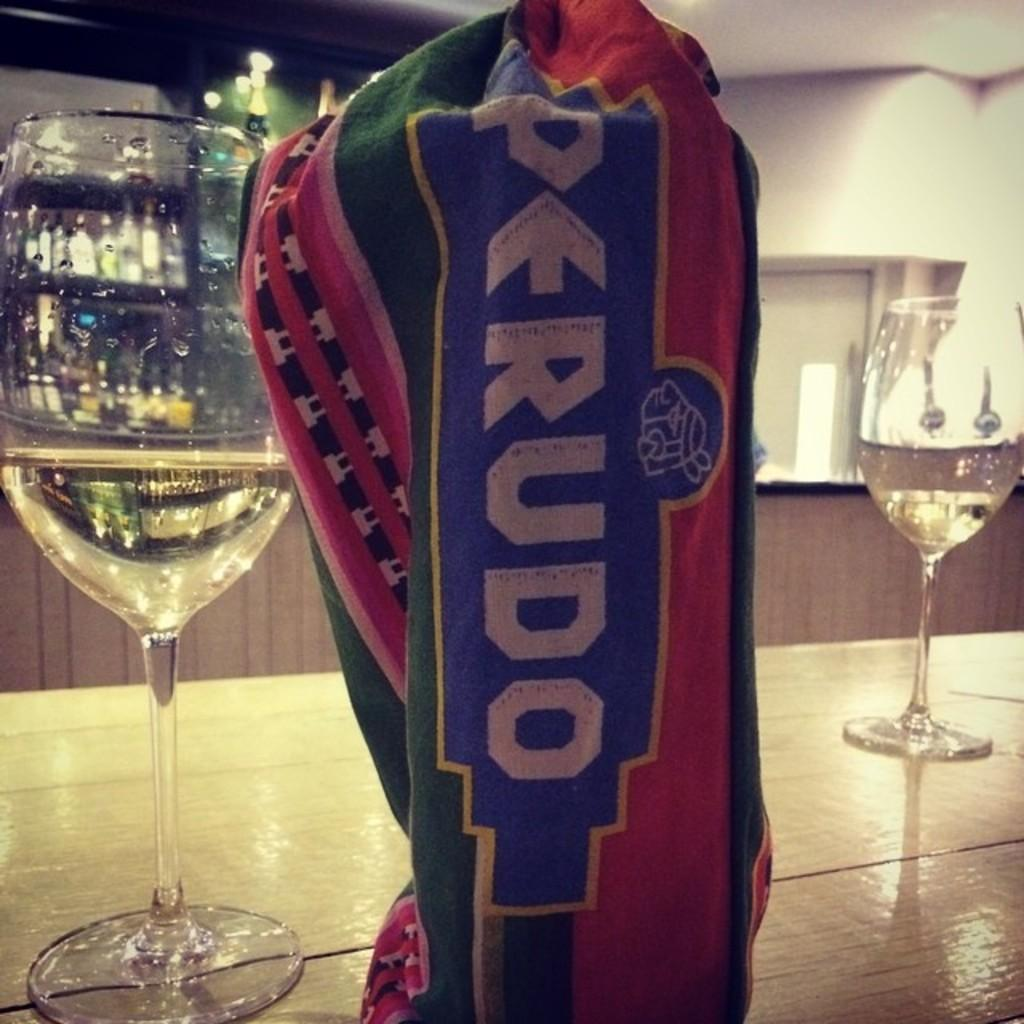<image>
Present a compact description of the photo's key features. multicour cloth with perudo on it next to some half full wine glasses 